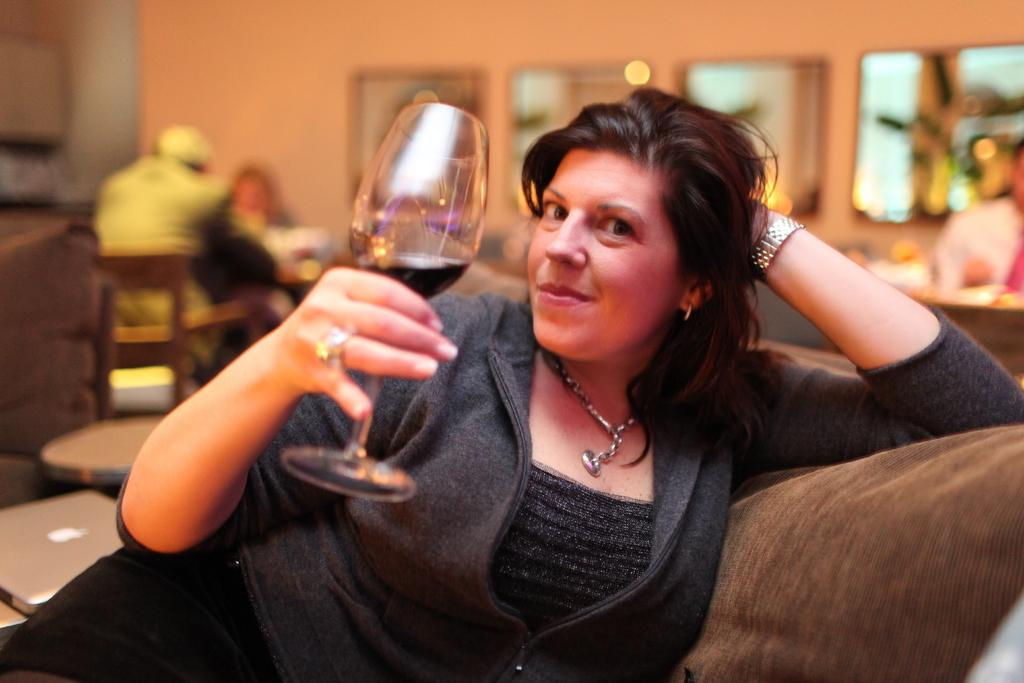Who is present in the image? There is a woman and a man in the image. What is the woman holding in the image? The woman is holding a glass. What is the woman's posture in the image? The woman is sitting. What object can be seen in the image related to technology? There is a laptop in the image. What is the man's posture in the image? The man is sitting on a chair. What type of fruit is the woman using to whip the man in the image? There is no fruit or whipping action present in the image. 